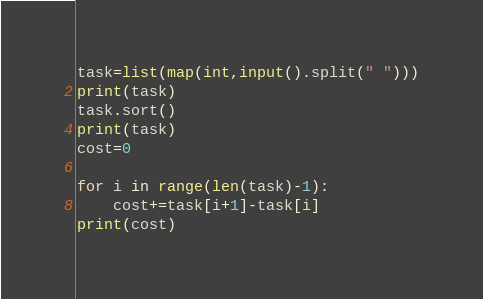Convert code to text. <code><loc_0><loc_0><loc_500><loc_500><_Python_>task=list(map(int,input().split(" ")))
print(task)
task.sort()
print(task)
cost=0

for i in range(len(task)-1):
    cost+=task[i+1]-task[i]
print(cost)</code> 